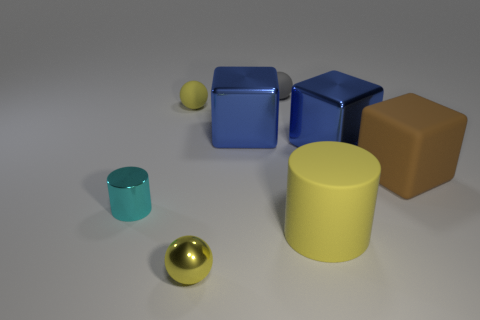There is a tiny object that is both in front of the large matte cube and behind the large cylinder; what shape is it?
Provide a short and direct response. Cylinder. There is a large object that is on the left side of the tiny object that is right of the tiny yellow shiny thing; what number of large blue metal things are in front of it?
Offer a very short reply. 1. What size is the yellow thing that is the same shape as the cyan object?
Make the answer very short. Large. Does the cylinder to the right of the cyan thing have the same material as the cyan thing?
Provide a short and direct response. No. What is the color of the other thing that is the same shape as the cyan object?
Offer a very short reply. Yellow. How many other objects are the same color as the large rubber cylinder?
Ensure brevity in your answer.  2. There is a small rubber thing that is to the left of the tiny metal sphere; is it the same shape as the tiny metallic thing that is in front of the tiny cyan shiny cylinder?
Offer a very short reply. Yes. What number of blocks are either shiny objects or yellow matte things?
Make the answer very short. 2. Is the number of small rubber spheres that are to the right of the brown matte thing less than the number of purple metal cubes?
Ensure brevity in your answer.  No. What number of other objects are the same material as the tiny cylinder?
Provide a succinct answer. 3. 